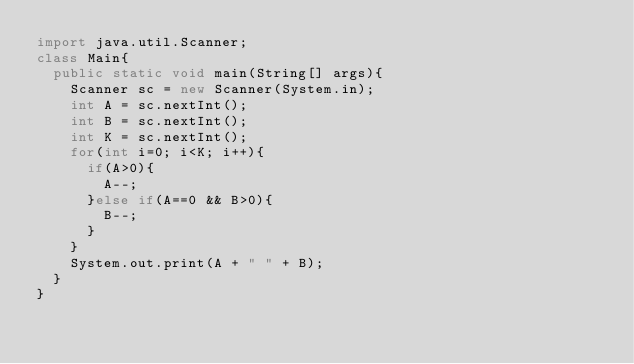<code> <loc_0><loc_0><loc_500><loc_500><_Java_>import java.util.Scanner;
class Main{
  public static void main(String[] args){
    Scanner sc = new Scanner(System.in);
    int A = sc.nextInt();
    int B = sc.nextInt();
    int K = sc.nextInt();
    for(int i=0; i<K; i++){
      if(A>0){
        A--;
      }else if(A==0 && B>0){
        B--;
      }
    }
    System.out.print(A + " " + B);
  }
}
</code> 